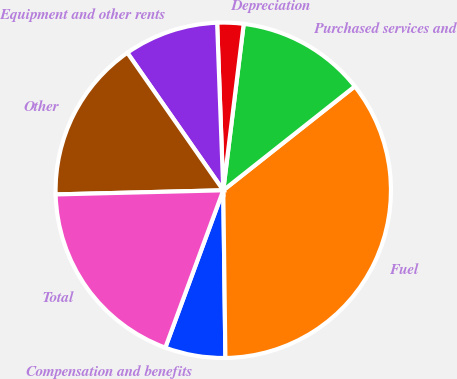Convert chart. <chart><loc_0><loc_0><loc_500><loc_500><pie_chart><fcel>Compensation and benefits<fcel>Fuel<fcel>Purchased services and<fcel>Depreciation<fcel>Equipment and other rents<fcel>Other<fcel>Total<nl><fcel>5.82%<fcel>35.44%<fcel>12.41%<fcel>2.53%<fcel>9.11%<fcel>15.7%<fcel>18.99%<nl></chart> 